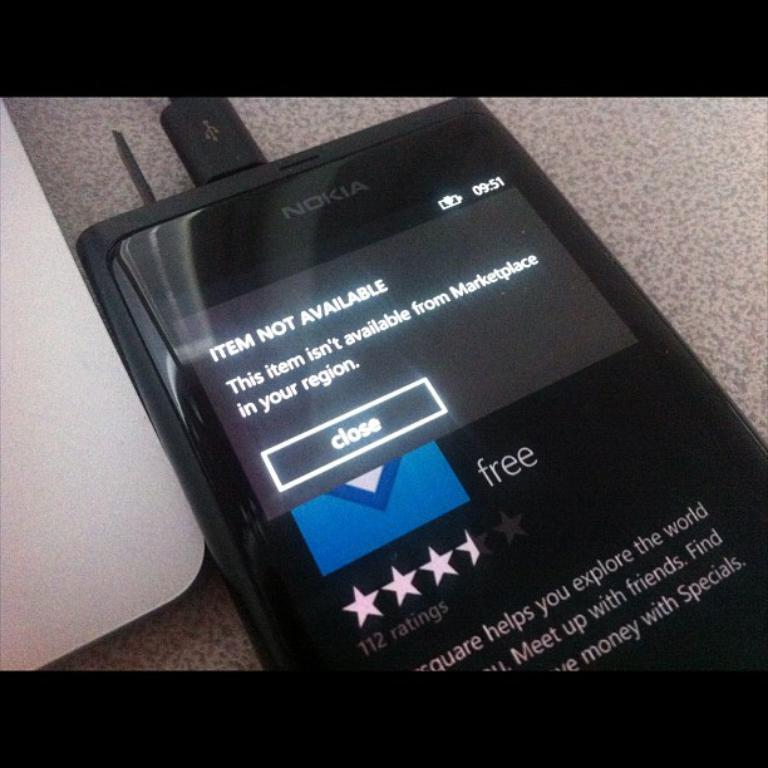<image>
Provide a brief description of the given image. A black Nokia brand cellphone with the display screen displaying Item Not Available and a close button 